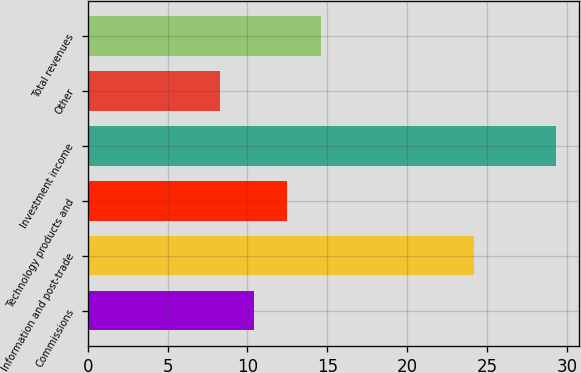<chart> <loc_0><loc_0><loc_500><loc_500><bar_chart><fcel>Commissions<fcel>Information and post-trade<fcel>Technology products and<fcel>Investment income<fcel>Other<fcel>Total revenues<nl><fcel>10.4<fcel>24.2<fcel>12.5<fcel>29.3<fcel>8.3<fcel>14.6<nl></chart> 